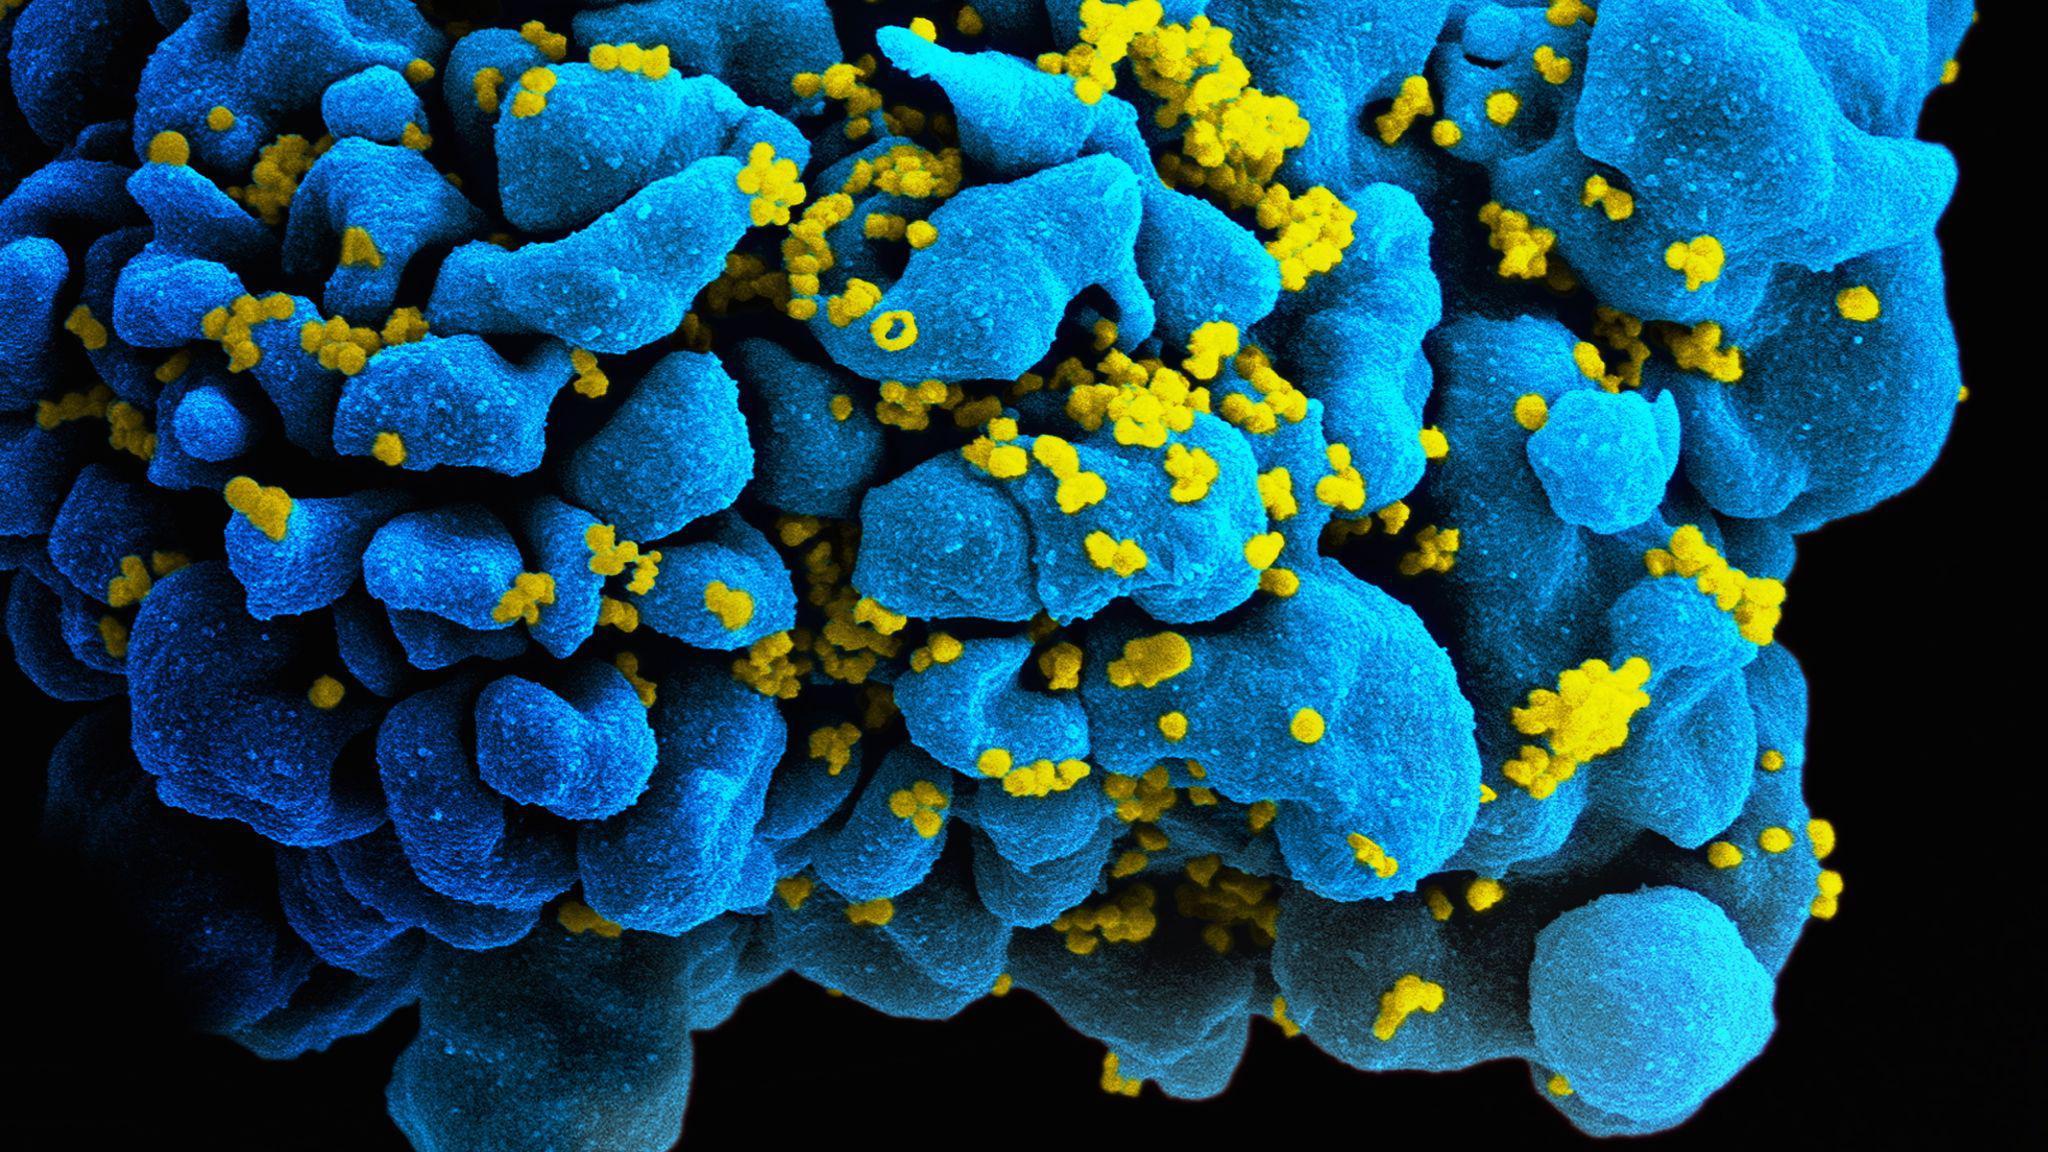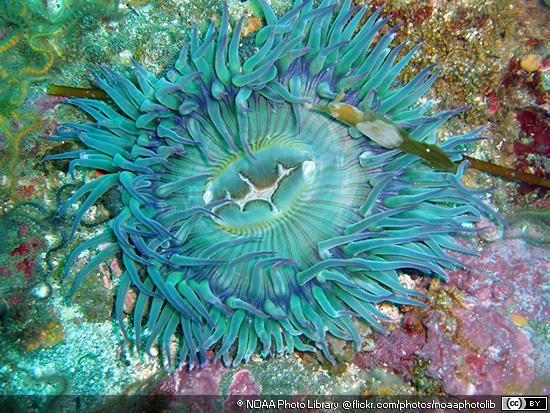The first image is the image on the left, the second image is the image on the right. Given the left and right images, does the statement "The left image contains only pink anemone, and the right image includes an anemone with tendrils sprouting upward." hold true? Answer yes or no. No. The first image is the image on the left, the second image is the image on the right. Examine the images to the left and right. Is the description "The anemones in the left image is pink." accurate? Answer yes or no. No. 